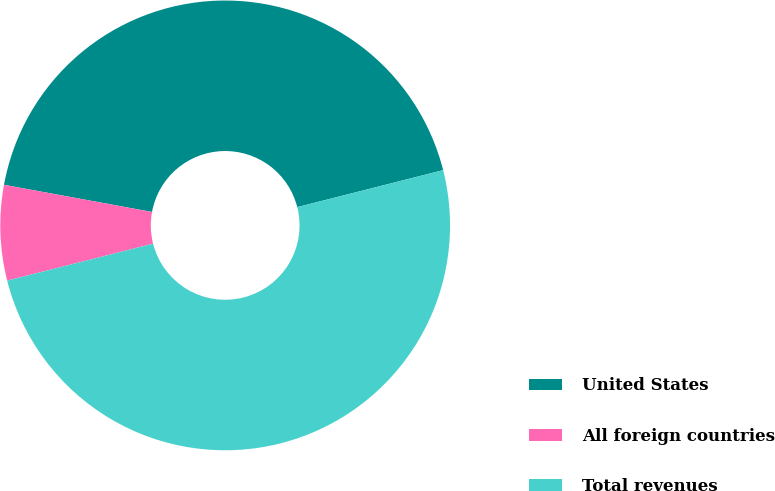Convert chart. <chart><loc_0><loc_0><loc_500><loc_500><pie_chart><fcel>United States<fcel>All foreign countries<fcel>Total revenues<nl><fcel>43.16%<fcel>6.84%<fcel>50.0%<nl></chart> 